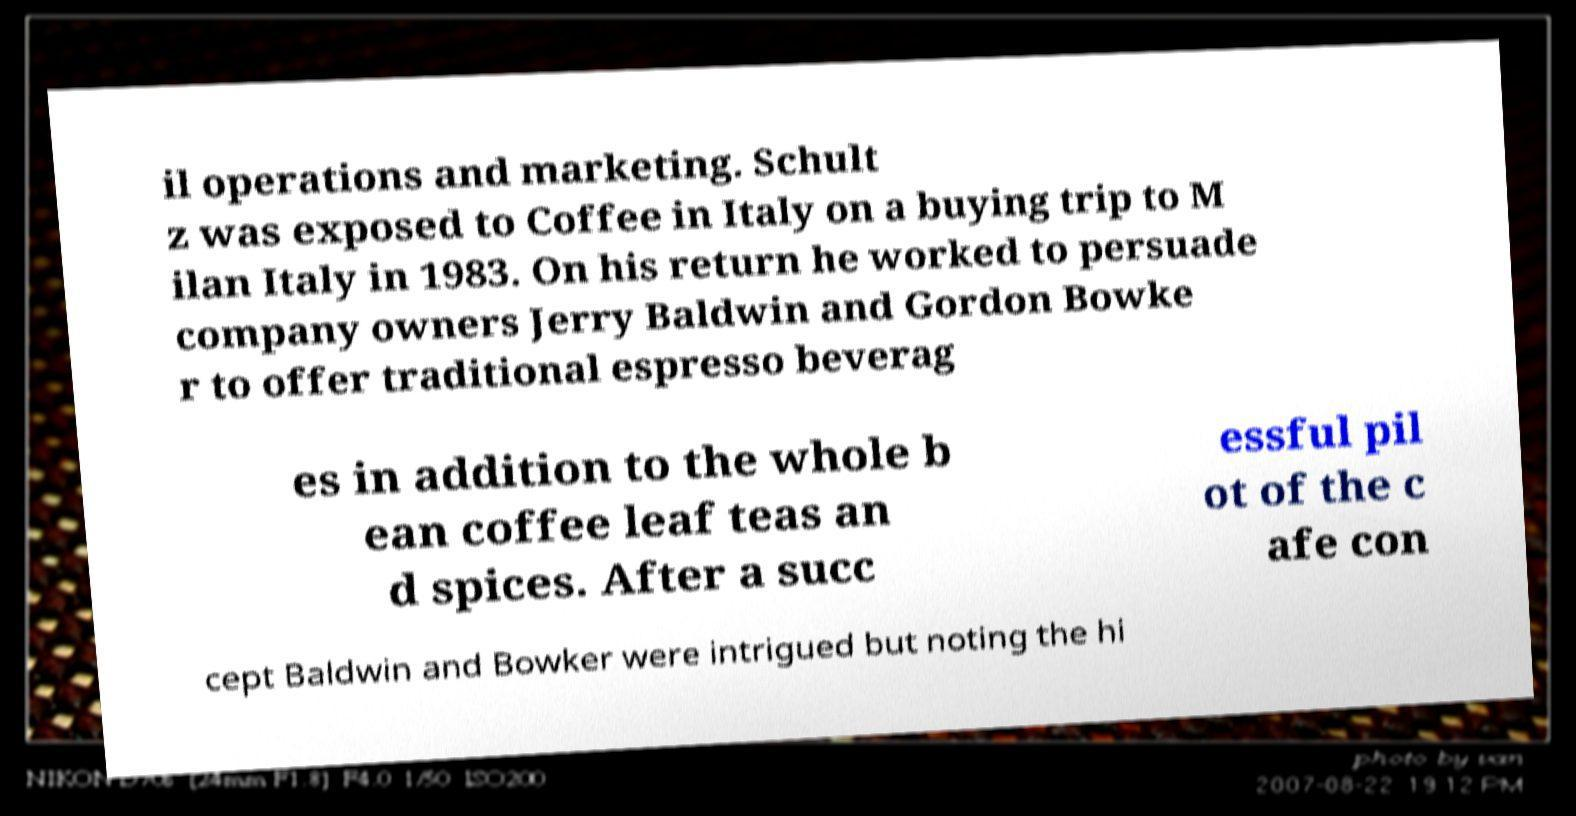Could you assist in decoding the text presented in this image and type it out clearly? il operations and marketing. Schult z was exposed to Coffee in Italy on a buying trip to M ilan Italy in 1983. On his return he worked to persuade company owners Jerry Baldwin and Gordon Bowke r to offer traditional espresso beverag es in addition to the whole b ean coffee leaf teas an d spices. After a succ essful pil ot of the c afe con cept Baldwin and Bowker were intrigued but noting the hi 